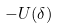Convert formula to latex. <formula><loc_0><loc_0><loc_500><loc_500>- U ( \delta )</formula> 